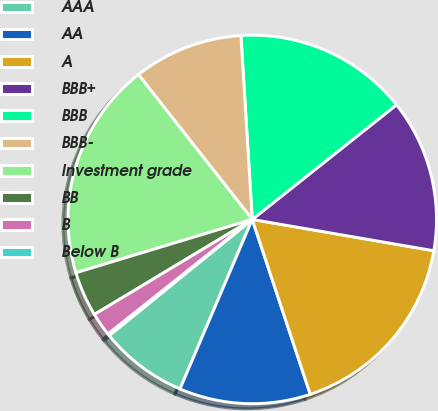Convert chart. <chart><loc_0><loc_0><loc_500><loc_500><pie_chart><fcel>AAA<fcel>AA<fcel>A<fcel>BBB+<fcel>BBB<fcel>BBB-<fcel>Investment grade<fcel>BB<fcel>B<fcel>Below B<nl><fcel>7.73%<fcel>11.51%<fcel>17.18%<fcel>13.4%<fcel>15.29%<fcel>9.62%<fcel>19.07%<fcel>3.95%<fcel>2.06%<fcel>0.17%<nl></chart> 